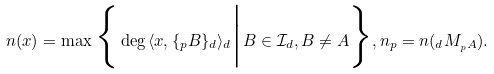<formula> <loc_0><loc_0><loc_500><loc_500>n ( x ) = \max \Big \{ \deg \, \langle x , \{ _ { p } B \} _ { d } \rangle _ { d } \Big | B \in \mathcal { I } _ { d } , B \neq A \Big \} , n _ { p } = n ( _ { d } M _ { _ { p } A } ) .</formula> 